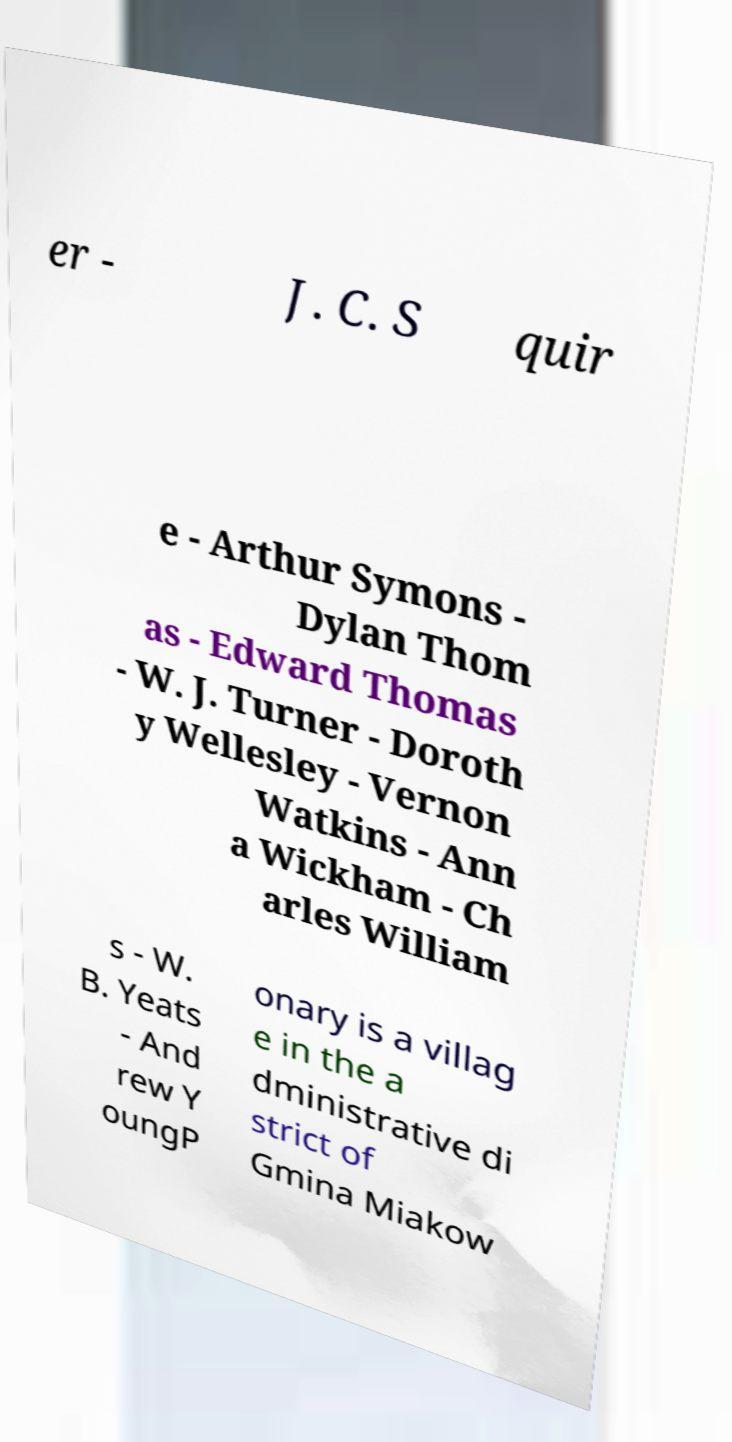For documentation purposes, I need the text within this image transcribed. Could you provide that? er - J. C. S quir e - Arthur Symons - Dylan Thom as - Edward Thomas - W. J. Turner - Doroth y Wellesley - Vernon Watkins - Ann a Wickham - Ch arles William s - W. B. Yeats - And rew Y oungP onary is a villag e in the a dministrative di strict of Gmina Miakow 